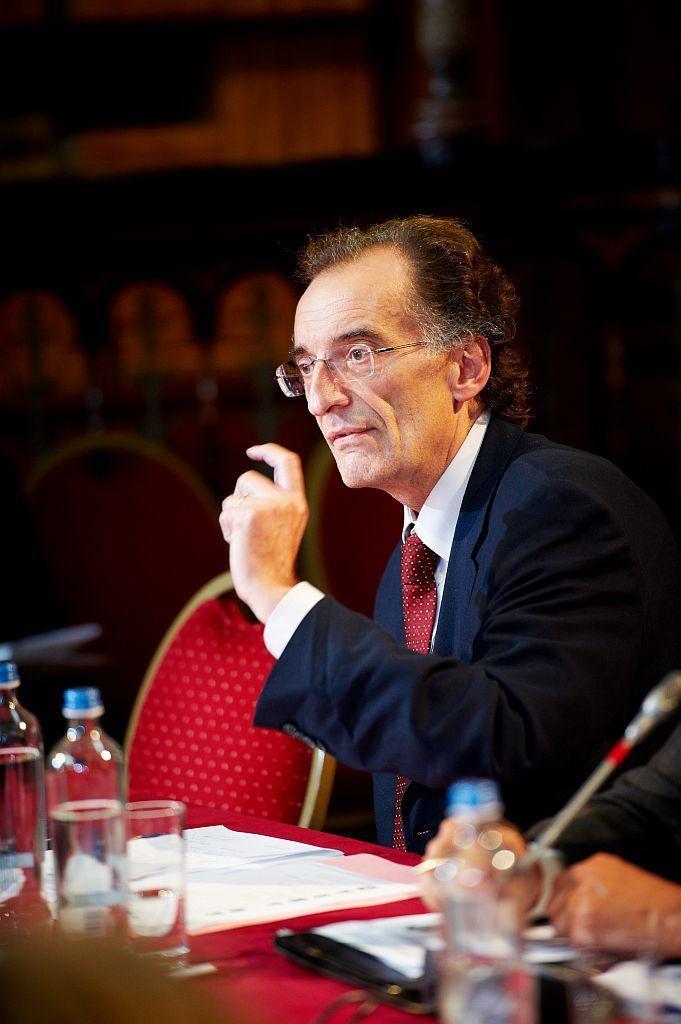Please provide a concise description of this image. In this picture we can see man wore blazer, tie, spectacle sitting on chair and talking beside to him there is other person and in front of them there is table and on table we can see glass, paper, file and in background we can see wall, some more chairs. 